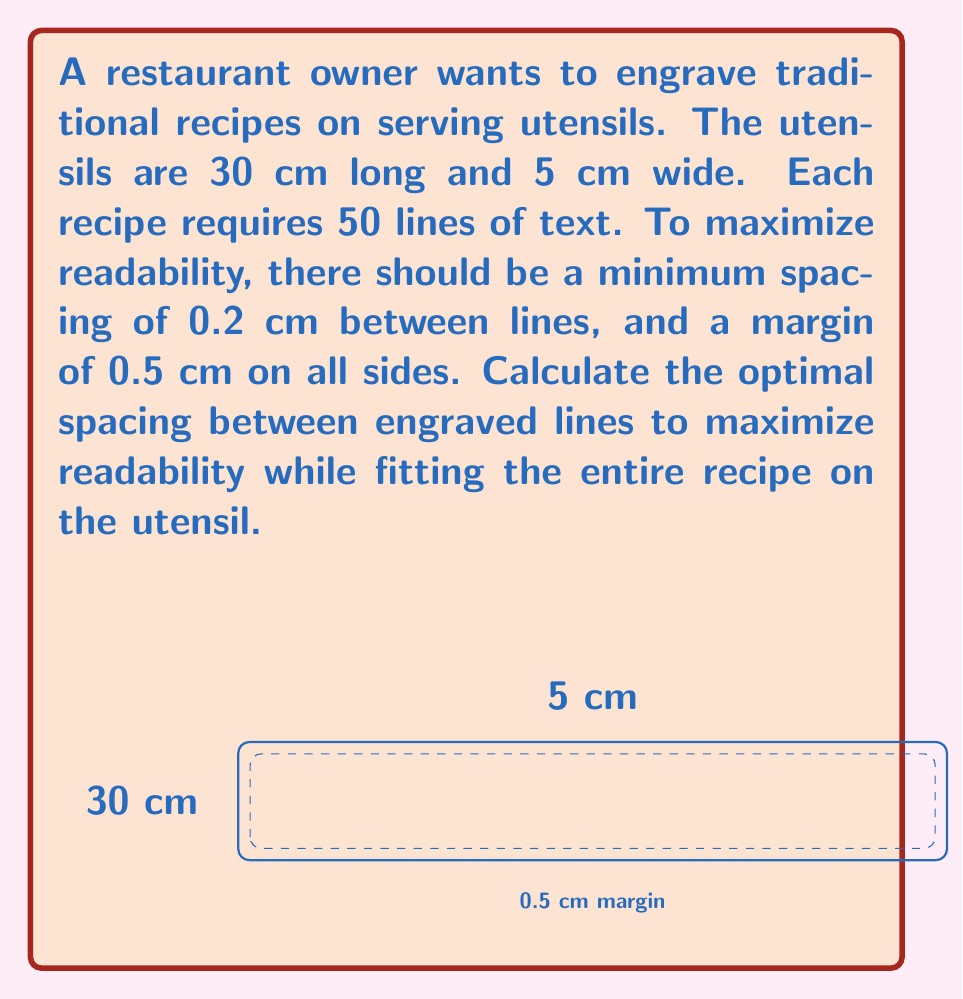Can you solve this math problem? Let's approach this step-by-step:

1) First, we need to calculate the available space for engraving:
   Length: $30 - (2 \times 0.5) = 29$ cm
   Width: $5 - (2 \times 0.5) = 4$ cm

2) The available height for the 50 lines is 4 cm.

3) Let $x$ be the spacing between lines. Then the total space taken by the lines and spaces is:
   $$(50 \times \text{line thickness}) + (49 \times x) = 4$$

4) We know the minimum spacing is 0.2 cm, so the line thickness must be:
   $$(4 - (49 \times 0.2)) \div 50 = 0.0042$ cm

5) Now we can set up our equation:
   $$(50 \times 0.0042) + (49 \times x) = 4$$

6) Simplify:
   $$0.21 + 49x = 4$$

7) Solve for $x$:
   $$49x = 3.79$$
   $$x = 3.79 \div 49 \approx 0.0773$ cm

8) Round to the nearest hundredth:
   $$x \approx 0.08$ cm

Therefore, the optimal spacing between lines is 0.08 cm.
Answer: 0.08 cm 